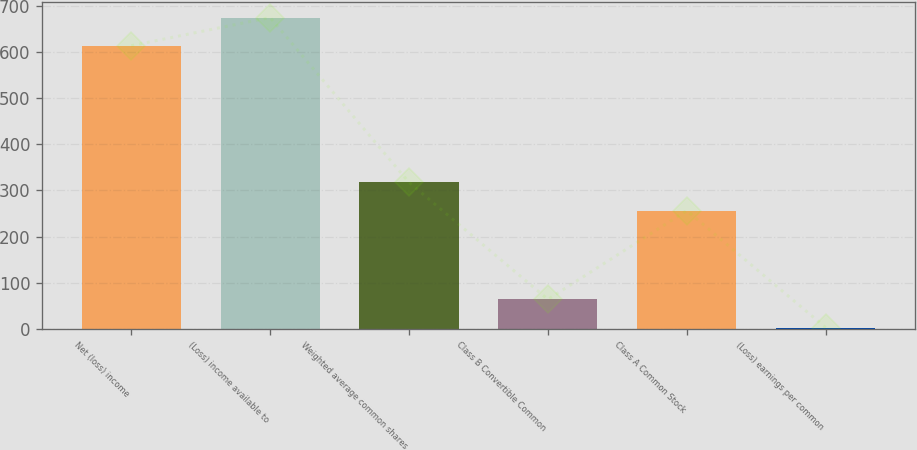Convert chart to OTSL. <chart><loc_0><loc_0><loc_500><loc_500><bar_chart><fcel>Net (loss) income<fcel>(Loss) income available to<fcel>Weighted average common shares<fcel>Class B Convertible Common<fcel>Class A Common Stock<fcel>(Loss) earnings per common<nl><fcel>613.3<fcel>674.35<fcel>317.23<fcel>63.88<fcel>256.18<fcel>2.83<nl></chart> 